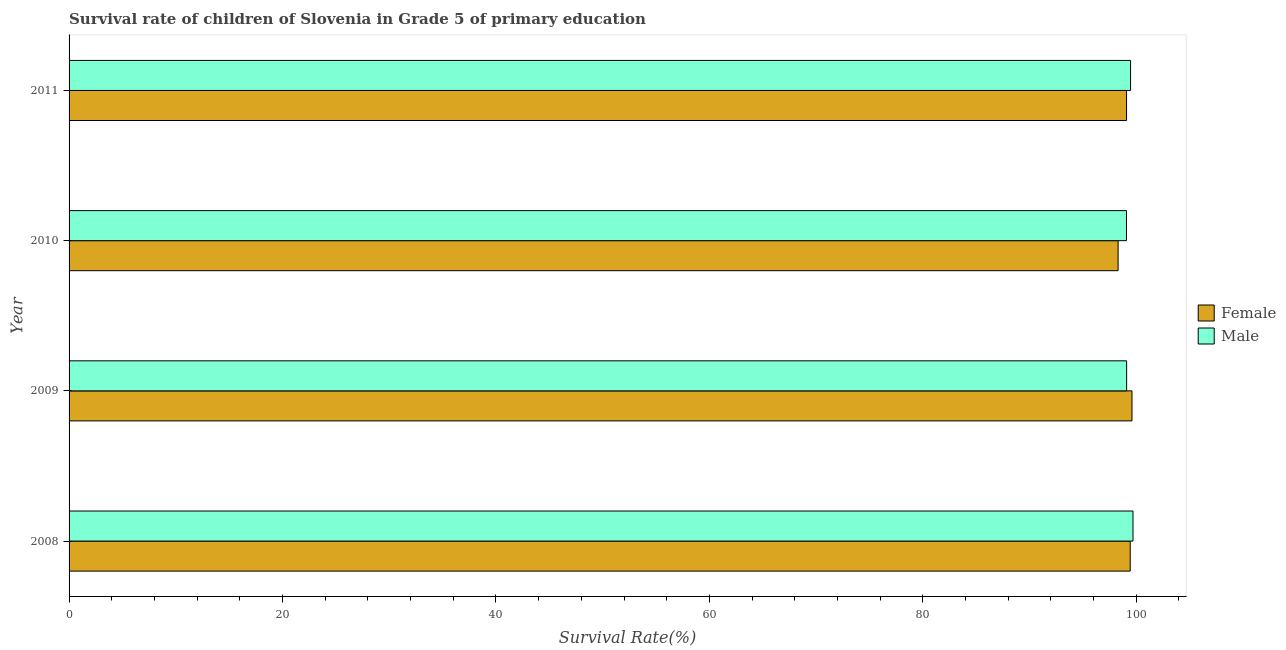How many groups of bars are there?
Offer a very short reply. 4. How many bars are there on the 2nd tick from the top?
Your response must be concise. 2. How many bars are there on the 2nd tick from the bottom?
Your answer should be very brief. 2. In how many cases, is the number of bars for a given year not equal to the number of legend labels?
Ensure brevity in your answer.  0. What is the survival rate of female students in primary education in 2009?
Keep it short and to the point. 99.6. Across all years, what is the maximum survival rate of female students in primary education?
Ensure brevity in your answer.  99.6. Across all years, what is the minimum survival rate of male students in primary education?
Your answer should be very brief. 99.08. In which year was the survival rate of female students in primary education minimum?
Provide a succinct answer. 2010. What is the total survival rate of male students in primary education in the graph?
Make the answer very short. 397.34. What is the difference between the survival rate of male students in primary education in 2008 and that in 2009?
Provide a succinct answer. 0.6. What is the difference between the survival rate of female students in primary education in 2010 and the survival rate of male students in primary education in 2011?
Your answer should be very brief. -1.17. What is the average survival rate of male students in primary education per year?
Offer a terse response. 99.33. In the year 2009, what is the difference between the survival rate of male students in primary education and survival rate of female students in primary education?
Make the answer very short. -0.5. Is the survival rate of male students in primary education in 2009 less than that in 2011?
Offer a terse response. Yes. What is the difference between the highest and the second highest survival rate of female students in primary education?
Your answer should be very brief. 0.17. In how many years, is the survival rate of female students in primary education greater than the average survival rate of female students in primary education taken over all years?
Offer a terse response. 2. What does the 1st bar from the bottom in 2011 represents?
Your answer should be very brief. Female. How many bars are there?
Give a very brief answer. 8. Does the graph contain any zero values?
Keep it short and to the point. No. Where does the legend appear in the graph?
Your answer should be very brief. Center right. How many legend labels are there?
Ensure brevity in your answer.  2. What is the title of the graph?
Offer a very short reply. Survival rate of children of Slovenia in Grade 5 of primary education. What is the label or title of the X-axis?
Keep it short and to the point. Survival Rate(%). What is the label or title of the Y-axis?
Offer a very short reply. Year. What is the Survival Rate(%) in Female in 2008?
Give a very brief answer. 99.43. What is the Survival Rate(%) in Male in 2008?
Make the answer very short. 99.69. What is the Survival Rate(%) in Female in 2009?
Keep it short and to the point. 99.6. What is the Survival Rate(%) in Male in 2009?
Provide a succinct answer. 99.1. What is the Survival Rate(%) in Female in 2010?
Your response must be concise. 98.3. What is the Survival Rate(%) of Male in 2010?
Provide a short and direct response. 99.08. What is the Survival Rate(%) of Female in 2011?
Give a very brief answer. 99.09. What is the Survival Rate(%) in Male in 2011?
Keep it short and to the point. 99.47. Across all years, what is the maximum Survival Rate(%) of Female?
Provide a succinct answer. 99.6. Across all years, what is the maximum Survival Rate(%) of Male?
Provide a succinct answer. 99.69. Across all years, what is the minimum Survival Rate(%) in Female?
Offer a terse response. 98.3. Across all years, what is the minimum Survival Rate(%) of Male?
Provide a short and direct response. 99.08. What is the total Survival Rate(%) of Female in the graph?
Your response must be concise. 396.42. What is the total Survival Rate(%) in Male in the graph?
Offer a terse response. 397.34. What is the difference between the Survival Rate(%) in Female in 2008 and that in 2009?
Ensure brevity in your answer.  -0.17. What is the difference between the Survival Rate(%) in Male in 2008 and that in 2009?
Provide a succinct answer. 0.6. What is the difference between the Survival Rate(%) of Female in 2008 and that in 2010?
Give a very brief answer. 1.13. What is the difference between the Survival Rate(%) in Male in 2008 and that in 2010?
Provide a succinct answer. 0.61. What is the difference between the Survival Rate(%) of Female in 2008 and that in 2011?
Your answer should be compact. 0.34. What is the difference between the Survival Rate(%) of Male in 2008 and that in 2011?
Your response must be concise. 0.23. What is the difference between the Survival Rate(%) in Female in 2009 and that in 2010?
Your response must be concise. 1.3. What is the difference between the Survival Rate(%) in Male in 2009 and that in 2010?
Provide a succinct answer. 0.01. What is the difference between the Survival Rate(%) of Female in 2009 and that in 2011?
Your answer should be very brief. 0.51. What is the difference between the Survival Rate(%) in Male in 2009 and that in 2011?
Your answer should be very brief. -0.37. What is the difference between the Survival Rate(%) of Female in 2010 and that in 2011?
Give a very brief answer. -0.79. What is the difference between the Survival Rate(%) of Male in 2010 and that in 2011?
Make the answer very short. -0.38. What is the difference between the Survival Rate(%) of Female in 2008 and the Survival Rate(%) of Male in 2009?
Your answer should be very brief. 0.33. What is the difference between the Survival Rate(%) of Female in 2008 and the Survival Rate(%) of Male in 2010?
Make the answer very short. 0.35. What is the difference between the Survival Rate(%) in Female in 2008 and the Survival Rate(%) in Male in 2011?
Make the answer very short. -0.03. What is the difference between the Survival Rate(%) in Female in 2009 and the Survival Rate(%) in Male in 2010?
Offer a very short reply. 0.52. What is the difference between the Survival Rate(%) of Female in 2009 and the Survival Rate(%) of Male in 2011?
Offer a terse response. 0.13. What is the difference between the Survival Rate(%) in Female in 2010 and the Survival Rate(%) in Male in 2011?
Keep it short and to the point. -1.17. What is the average Survival Rate(%) in Female per year?
Make the answer very short. 99.1. What is the average Survival Rate(%) of Male per year?
Give a very brief answer. 99.33. In the year 2008, what is the difference between the Survival Rate(%) in Female and Survival Rate(%) in Male?
Your response must be concise. -0.26. In the year 2009, what is the difference between the Survival Rate(%) of Female and Survival Rate(%) of Male?
Your answer should be very brief. 0.5. In the year 2010, what is the difference between the Survival Rate(%) of Female and Survival Rate(%) of Male?
Keep it short and to the point. -0.78. In the year 2011, what is the difference between the Survival Rate(%) in Female and Survival Rate(%) in Male?
Offer a very short reply. -0.38. What is the ratio of the Survival Rate(%) of Female in 2008 to that in 2009?
Give a very brief answer. 1. What is the ratio of the Survival Rate(%) of Female in 2008 to that in 2010?
Your answer should be very brief. 1.01. What is the ratio of the Survival Rate(%) in Male in 2008 to that in 2010?
Give a very brief answer. 1.01. What is the ratio of the Survival Rate(%) in Female in 2008 to that in 2011?
Make the answer very short. 1. What is the ratio of the Survival Rate(%) in Female in 2009 to that in 2010?
Offer a terse response. 1.01. What is the ratio of the Survival Rate(%) in Male in 2009 to that in 2011?
Provide a succinct answer. 1. What is the ratio of the Survival Rate(%) of Female in 2010 to that in 2011?
Keep it short and to the point. 0.99. What is the difference between the highest and the second highest Survival Rate(%) in Female?
Ensure brevity in your answer.  0.17. What is the difference between the highest and the second highest Survival Rate(%) of Male?
Provide a succinct answer. 0.23. What is the difference between the highest and the lowest Survival Rate(%) in Female?
Your answer should be compact. 1.3. What is the difference between the highest and the lowest Survival Rate(%) of Male?
Keep it short and to the point. 0.61. 